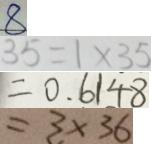Convert formula to latex. <formula><loc_0><loc_0><loc_500><loc_500>8 
 3 5 = 1 \times 3 5 
 = 0 . 6 1 4 8 
 = 3 \times 3 6</formula> 